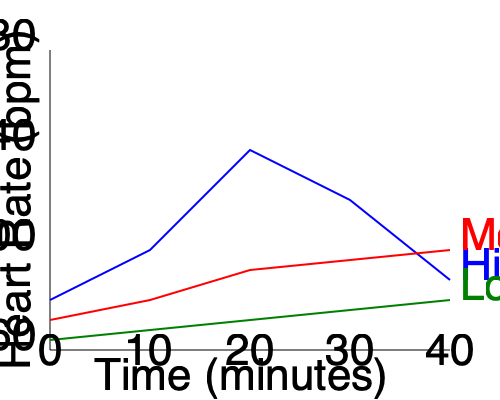Based on the line graph showing the impact of different exercise intensities on heart rate over time, which type of exercise would be most suitable for a senior looking to maintain a steady, moderate heart rate during a 40-minute workout? To determine the most suitable exercise type for a senior aiming to maintain a steady, moderate heart rate during a 40-minute workout, let's analyze the heart rate patterns for each intensity level:

1. High-Intensity (Blue line):
   - Starts at about 100 bpm
   - Peaks at around 140 bpm at 20 minutes
   - Ends at about 110 bpm
   - Shows significant fluctuations

2. Moderate-Intensity (Red line):
   - Starts at about 90 bpm
   - Gradually decreases to about 80 bpm
   - Shows a steady, consistent pattern

3. Low-Intensity (Green line):
   - Starts at about 70 bpm
   - Gradually decreases to about 60 bpm
   - Shows the least elevation in heart rate

For seniors, it's generally recommended to maintain a steady, moderate heart rate during exercise to avoid overexertion while still gaining cardiovascular benefits. The moderate-intensity exercise (red line) provides the most suitable option because:

1. It maintains a heart rate between 80-90 bpm, which is typically within the target heart rate zone for seniors.
2. It shows a steady, consistent pattern without significant fluctuations, reducing the risk of sudden strain on the heart.
3. It provides a sustained elevated heart rate compared to low-intensity exercise, offering more cardiovascular benefits.
4. It avoids the potentially risky peaks and valleys seen in the high-intensity exercise, which might be too challenging for some seniors.

Therefore, the moderate-intensity exercise would be the most appropriate choice for a senior looking to maintain a steady, moderate heart rate during a 40-minute workout.
Answer: Moderate-intensity exercise 